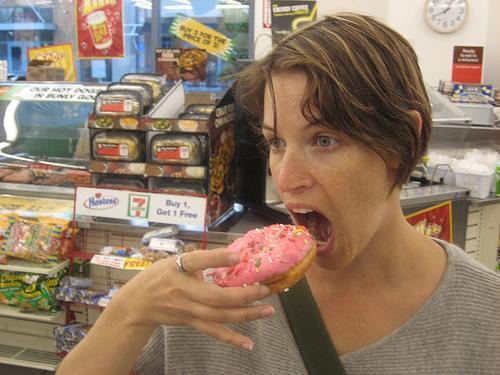How many doughnuts are there?
Give a very brief answer. 1. 